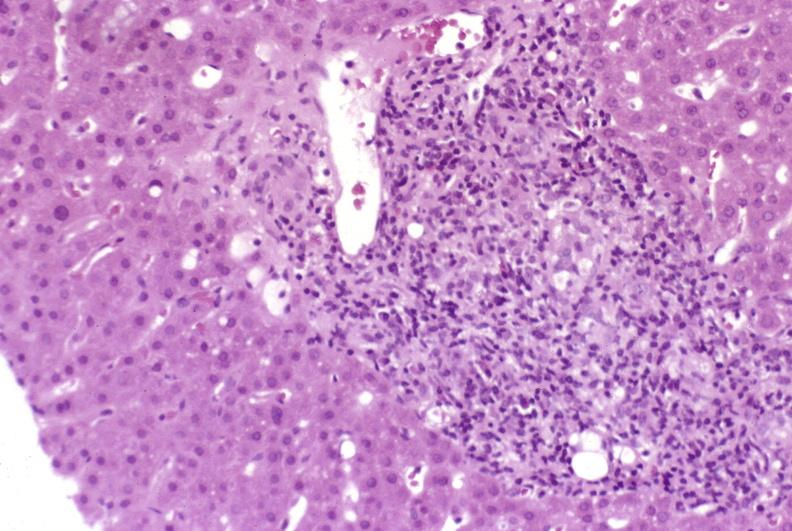what is present?
Answer the question using a single word or phrase. Hepatobiliary 